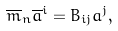Convert formula to latex. <formula><loc_0><loc_0><loc_500><loc_500>\overline { m } _ { n } \overline { a } ^ { i } = B _ { i j } a ^ { j } ,</formula> 